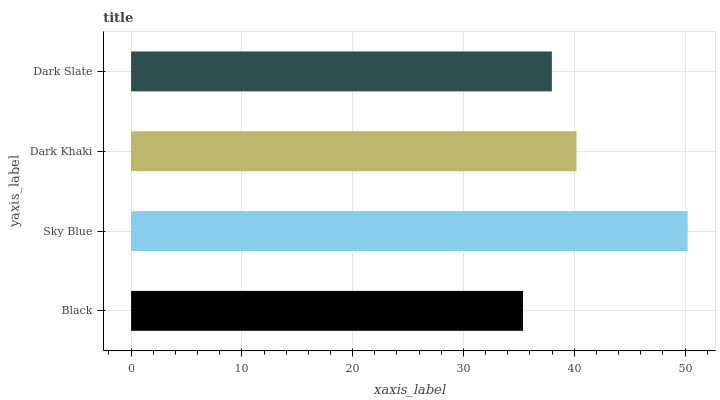Is Black the minimum?
Answer yes or no. Yes. Is Sky Blue the maximum?
Answer yes or no. Yes. Is Dark Khaki the minimum?
Answer yes or no. No. Is Dark Khaki the maximum?
Answer yes or no. No. Is Sky Blue greater than Dark Khaki?
Answer yes or no. Yes. Is Dark Khaki less than Sky Blue?
Answer yes or no. Yes. Is Dark Khaki greater than Sky Blue?
Answer yes or no. No. Is Sky Blue less than Dark Khaki?
Answer yes or no. No. Is Dark Khaki the high median?
Answer yes or no. Yes. Is Dark Slate the low median?
Answer yes or no. Yes. Is Sky Blue the high median?
Answer yes or no. No. Is Dark Khaki the low median?
Answer yes or no. No. 